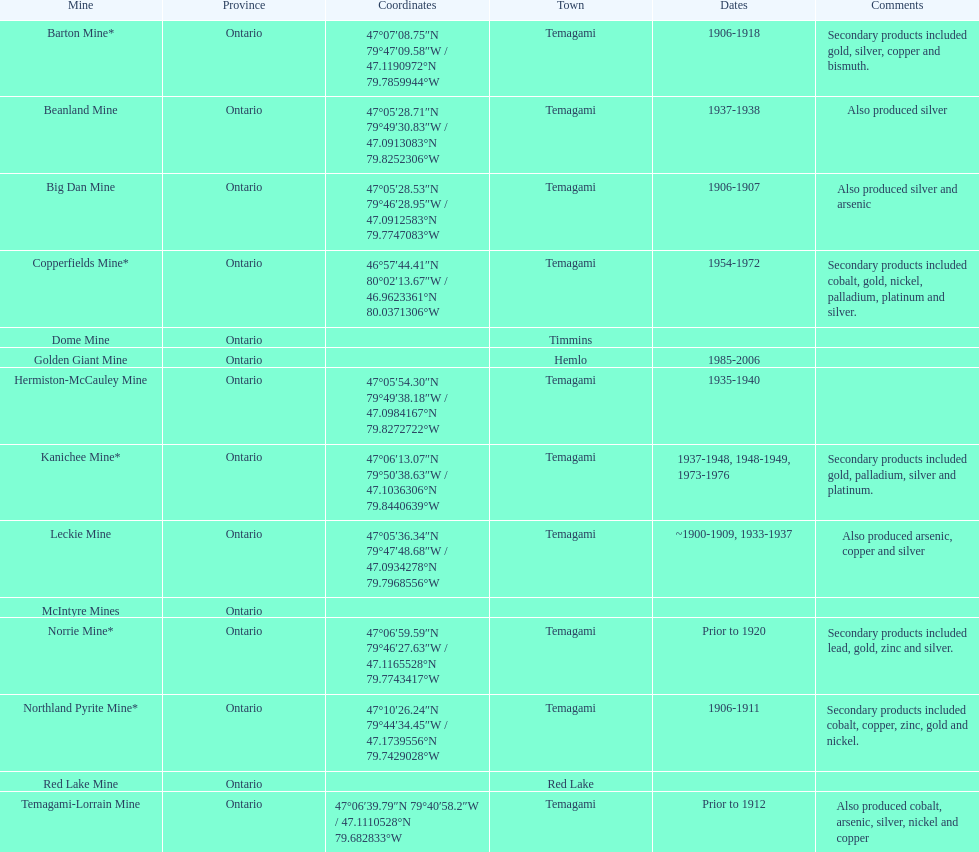What province is the town of temagami? Ontario. 